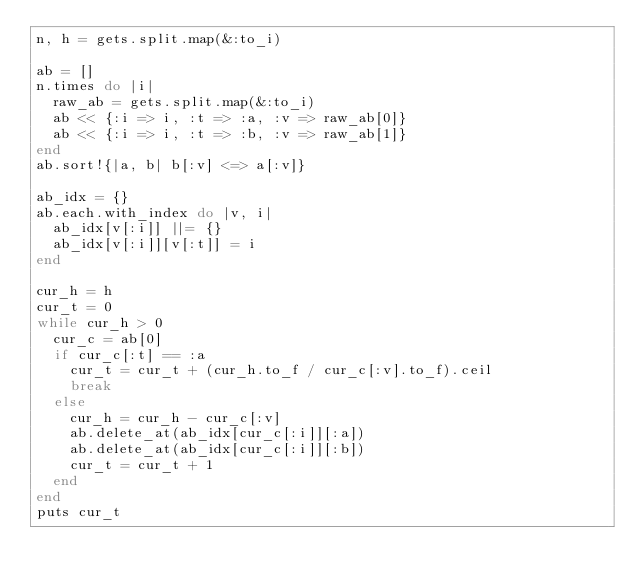<code> <loc_0><loc_0><loc_500><loc_500><_Ruby_>n, h = gets.split.map(&:to_i)

ab = []
n.times do |i|
  raw_ab = gets.split.map(&:to_i)
  ab << {:i => i, :t => :a, :v => raw_ab[0]}
  ab << {:i => i, :t => :b, :v => raw_ab[1]}
end
ab.sort!{|a, b| b[:v] <=> a[:v]}

ab_idx = {}
ab.each.with_index do |v, i|
  ab_idx[v[:i]] ||= {}
  ab_idx[v[:i]][v[:t]] = i
end

cur_h = h
cur_t = 0
while cur_h > 0
  cur_c = ab[0]
  if cur_c[:t] == :a
    cur_t = cur_t + (cur_h.to_f / cur_c[:v].to_f).ceil
    break
  else
    cur_h = cur_h - cur_c[:v]
    ab.delete_at(ab_idx[cur_c[:i]][:a])
    ab.delete_at(ab_idx[cur_c[:i]][:b])
    cur_t = cur_t + 1
  end
end
puts cur_t
</code> 